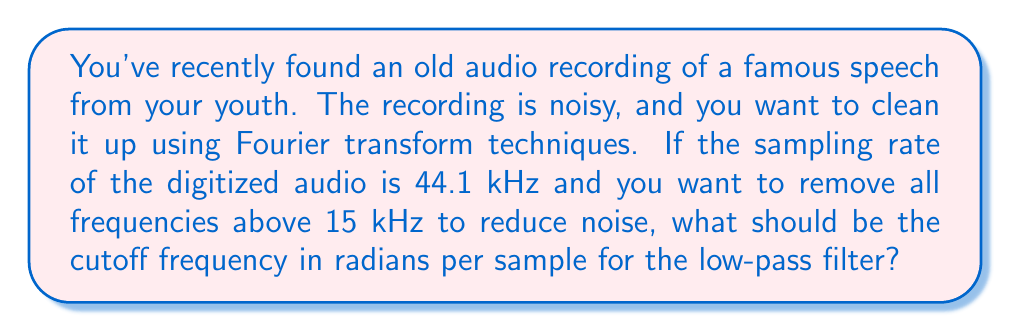Give your solution to this math problem. To solve this problem, we need to convert the given frequency in Hz to radians per sample. Here's how we can do it step-by-step:

1. We know the sampling rate $f_s = 44.1$ kHz = $44100$ Hz
2. The cutoff frequency $f_c = 15$ kHz = $15000$ Hz

To convert from Hz to radians per sample, we use the formula:

$$ \omega = 2\pi \frac{f}{f_s} $$

Where:
$\omega$ is the frequency in radians per sample
$f$ is the frequency in Hz
$f_s$ is the sampling rate in Hz

Plugging in our values:

$$ \omega = 2\pi \frac{15000}{44100} $$

$$ \omega = 2\pi (0.34013605442) $$

$$ \omega = 2.13628453346 \text{ radians per sample} $$

This is our cutoff frequency in radians per sample for the low-pass filter.
Answer: $2.13628453346 \text{ radians per sample}$ 